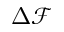Convert formula to latex. <formula><loc_0><loc_0><loc_500><loc_500>\Delta \mathcal { F }</formula> 